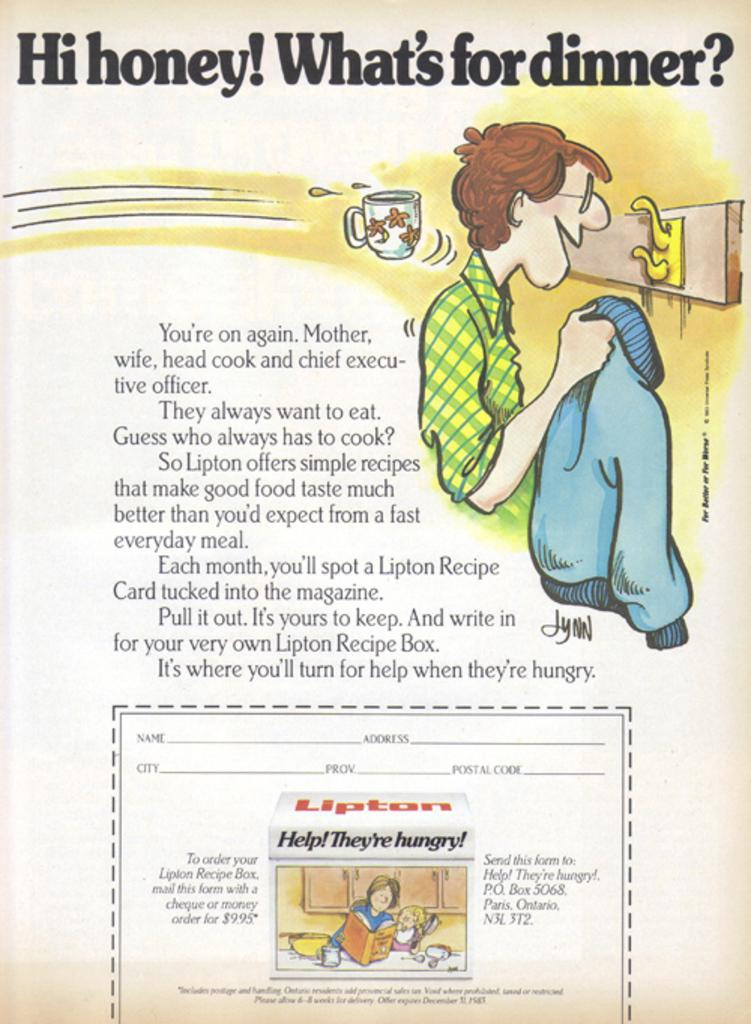What type of content is on the page in the image? The page contains an animated image. What is depicted in the animated image? The animated image includes a person and objects. Is there any text accompanying the animated image? Yes, there is a quotation is written beside the animated image. How many cows are present in the animated image? There are no cows depicted in the animated image; it features a person and objects. What type of match is being played in the image? There is no match or any game being played in the image; it contains an animated image with a person and objects, along with a quotation. 